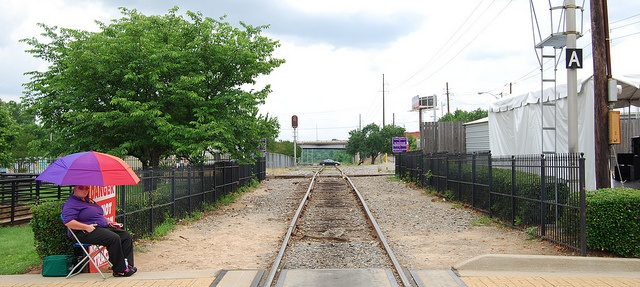Describe the objects in this image and their specific colors. I can see people in white, black, purple, and navy tones, umbrella in white, purple, magenta, and salmon tones, chair in white, black, lightgray, darkgray, and gray tones, car in white, black, darkgray, gray, and lightgray tones, and people in white, black, maroon, salmon, and gray tones in this image. 